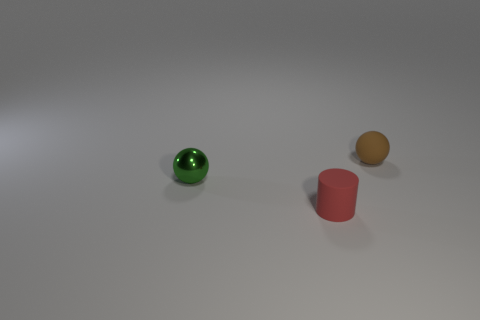Add 2 metal things. How many objects exist? 5 Subtract all balls. How many objects are left? 1 Subtract 0 gray spheres. How many objects are left? 3 Subtract all small matte spheres. Subtract all big blue metal balls. How many objects are left? 2 Add 2 red things. How many red things are left? 3 Add 1 green metal objects. How many green metal objects exist? 2 